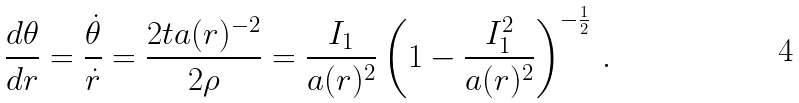<formula> <loc_0><loc_0><loc_500><loc_500>\frac { d \theta } { d r } = \frac { \dot { \theta } } { \dot { r } } = \frac { 2 t a ( r ) ^ { - 2 } } { 2 \rho } = \frac { I _ { 1 } } { a ( r ) ^ { 2 } } \left ( 1 - \frac { I _ { 1 } ^ { 2 } } { a ( r ) ^ { 2 } } \right ) ^ { - \frac { 1 } { 2 } } \, .</formula> 